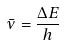Convert formula to latex. <formula><loc_0><loc_0><loc_500><loc_500>\bar { \nu } = \frac { \Delta E } { h }</formula> 